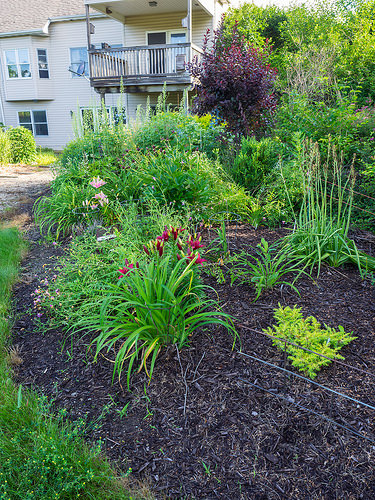<image>
Can you confirm if the plants is to the left of the house? No. The plants is not to the left of the house. From this viewpoint, they have a different horizontal relationship. Is the window behind the plant? Yes. From this viewpoint, the window is positioned behind the plant, with the plant partially or fully occluding the window. 